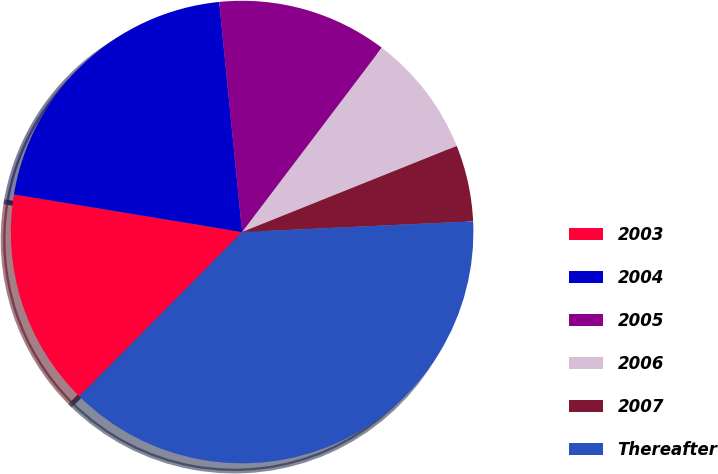Convert chart to OTSL. <chart><loc_0><loc_0><loc_500><loc_500><pie_chart><fcel>2003<fcel>2004<fcel>2005<fcel>2006<fcel>2007<fcel>Thereafter<nl><fcel>15.18%<fcel>20.82%<fcel>11.9%<fcel>8.61%<fcel>5.33%<fcel>38.16%<nl></chart> 